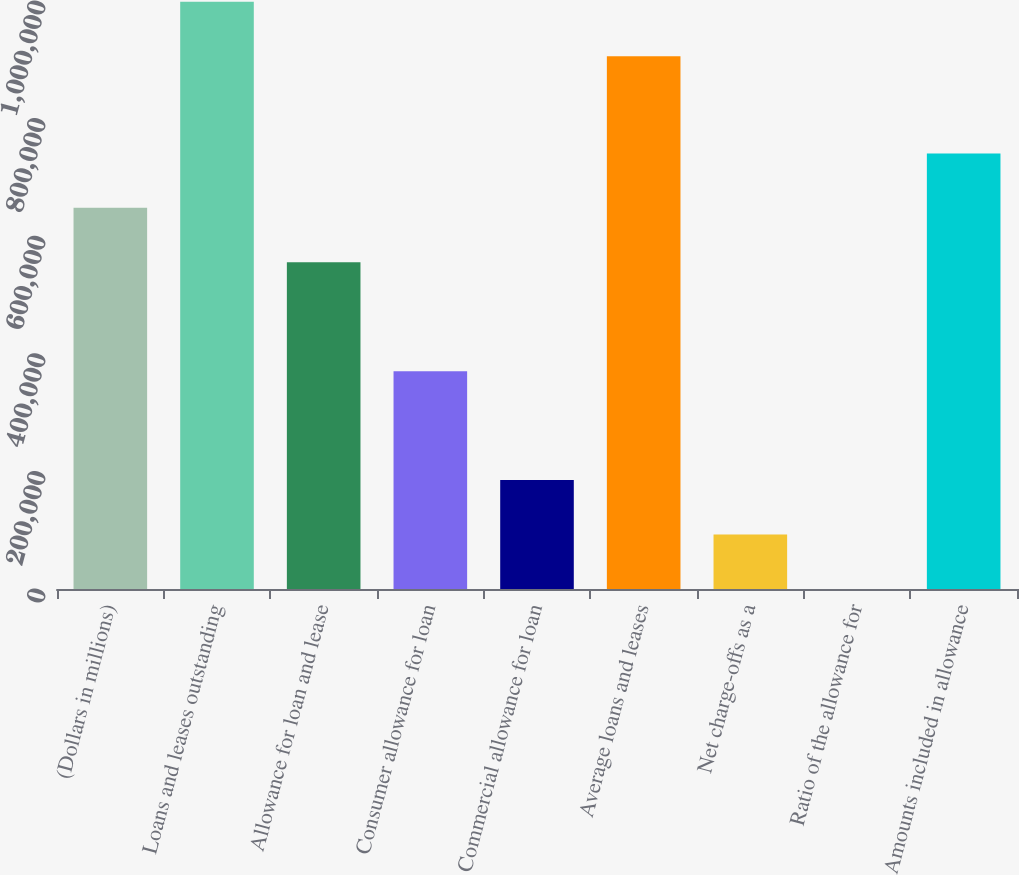<chart> <loc_0><loc_0><loc_500><loc_500><bar_chart><fcel>(Dollars in millions)<fcel>Loans and leases outstanding<fcel>Allowance for loan and lease<fcel>Consumer allowance for loan<fcel>Commercial allowance for loan<fcel>Average loans and leases<fcel>Net charge-offs as a<fcel>Ratio of the allowance for<fcel>Amounts included in allowance<nl><fcel>648224<fcel>998547<fcel>555620<fcel>370414<fcel>185208<fcel>905944<fcel>92604.6<fcel>1.42<fcel>740827<nl></chart> 